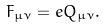<formula> <loc_0><loc_0><loc_500><loc_500>F _ { \mu \nu } = e Q _ { \mu \nu } .</formula> 